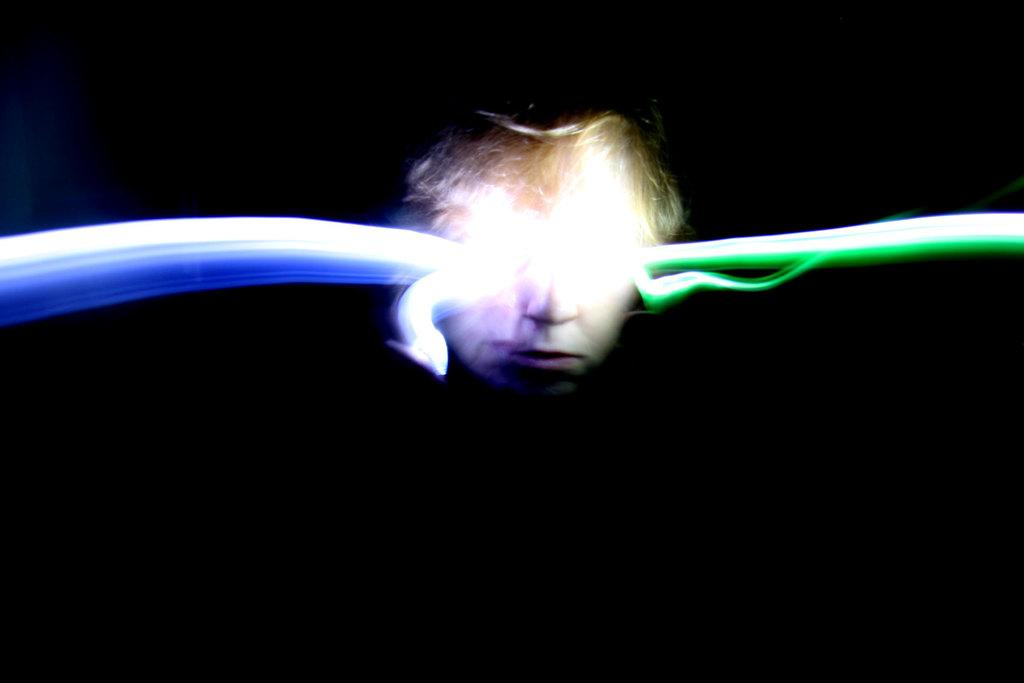What is the main subject in the middle of the image? There is a face in the middle of the image. What can be seen on the face in the image? There are light rays visible on the face. What type of cracker is being used to write a letter on the face in the image? There is no cracker or letter present in the image; it only features a face with light rays. 